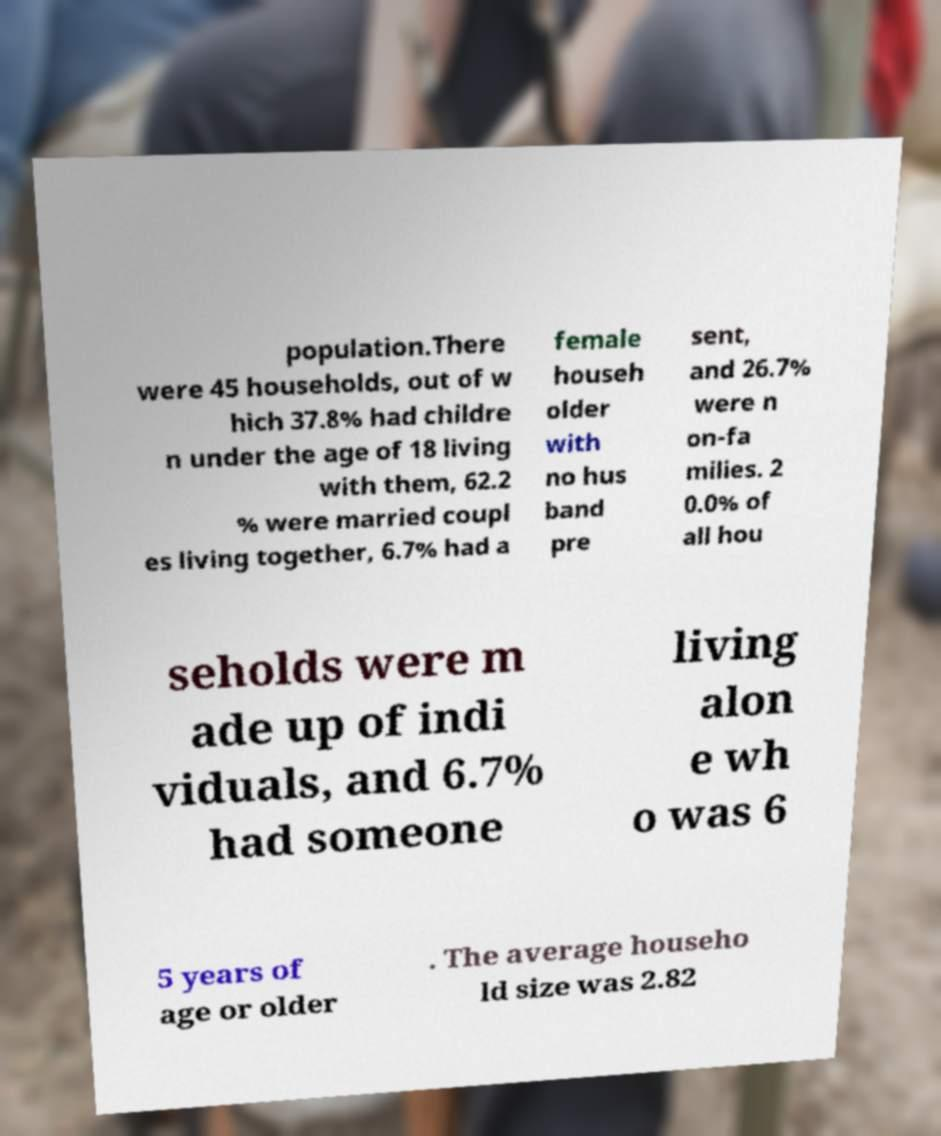What messages or text are displayed in this image? I need them in a readable, typed format. population.There were 45 households, out of w hich 37.8% had childre n under the age of 18 living with them, 62.2 % were married coupl es living together, 6.7% had a female househ older with no hus band pre sent, and 26.7% were n on-fa milies. 2 0.0% of all hou seholds were m ade up of indi viduals, and 6.7% had someone living alon e wh o was 6 5 years of age or older . The average househo ld size was 2.82 